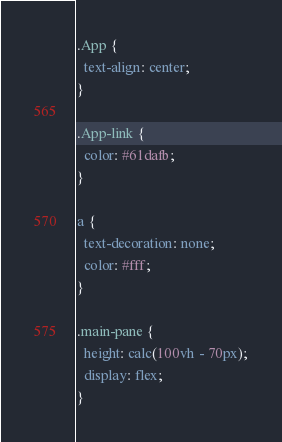<code> <loc_0><loc_0><loc_500><loc_500><_CSS_>.App {
  text-align: center;
}

.App-link {
  color: #61dafb;
}

a {
  text-decoration: none;
  color: #fff;
}

.main-pane {
  height: calc(100vh - 70px);
  display: flex;
}</code> 